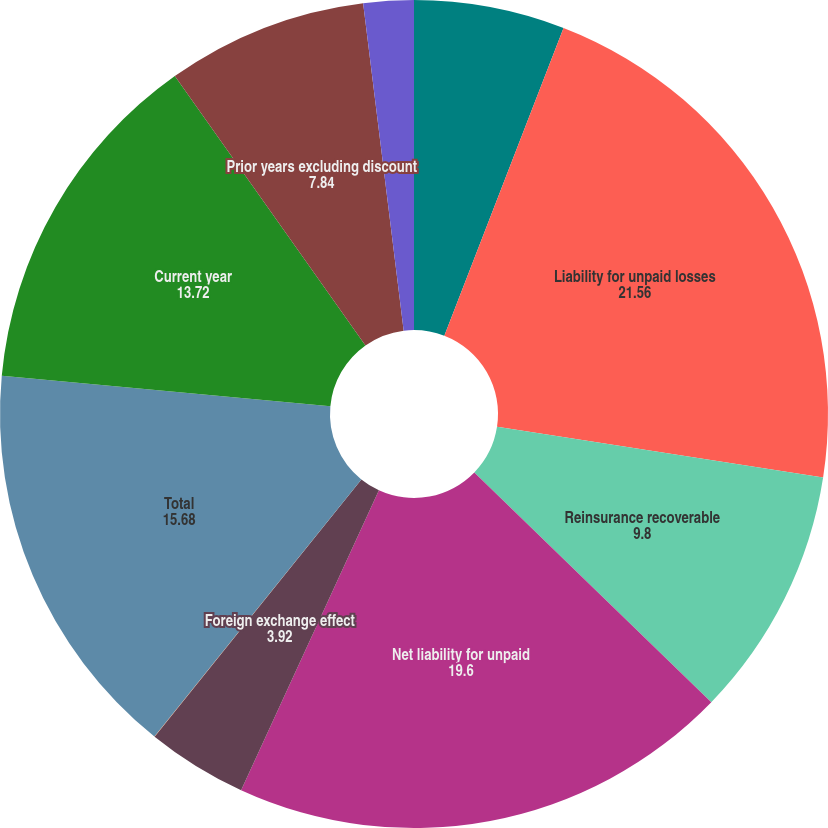Convert chart to OTSL. <chart><loc_0><loc_0><loc_500><loc_500><pie_chart><fcel>Years Ended December 31 (in<fcel>Liability for unpaid losses<fcel>Reinsurance recoverable<fcel>Net liability for unpaid<fcel>Foreign exchange effect<fcel>Changes in net loss reserves<fcel>Total<fcel>Current year<fcel>Prior years excluding discount<fcel>Prior years discount charge<nl><fcel>5.88%<fcel>21.56%<fcel>9.8%<fcel>19.6%<fcel>3.92%<fcel>0.01%<fcel>15.68%<fcel>13.72%<fcel>7.84%<fcel>1.96%<nl></chart> 